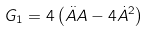<formula> <loc_0><loc_0><loc_500><loc_500>G _ { 1 } = 4 \left ( \ddot { A } A - 4 \dot { A } ^ { 2 } \right )</formula> 